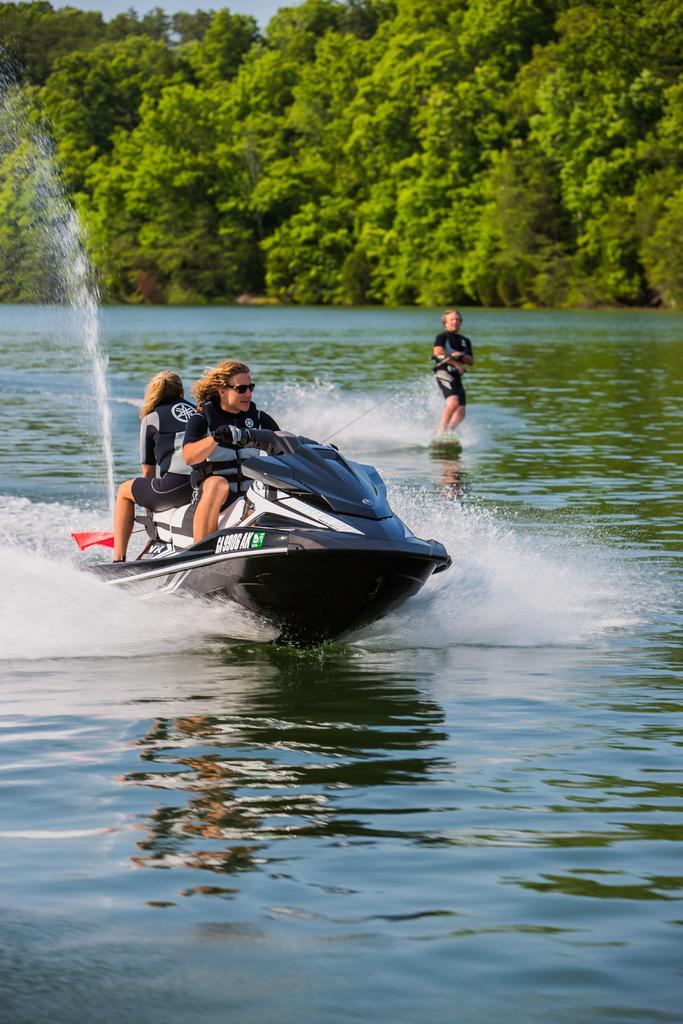Describe this image in one or two sentences. In this image we can see two persons on a jet ski. Behind them, there is a person standing in the water. Behind the water we can see a group of trees. At the top we can see the sky. 